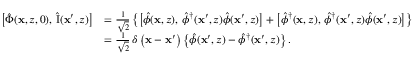Convert formula to latex. <formula><loc_0><loc_0><loc_500><loc_500>\begin{array} { r l } { \left [ \hat { \Phi } ( x , z , 0 ) , \, \hat { I } ( x ^ { \prime } , z ) \right ] } & { = \frac { 1 } { \sqrt { 2 } } \left \{ \left [ \hat { \phi } ( x , z ) , \, \hat { \phi } ^ { \dagger } ( x ^ { \prime } , z ) \hat { \phi } ( x ^ { \prime } , z ) \right ] + \left [ \hat { \phi } ^ { \dagger } ( x , z ) , \, \hat { \phi } ^ { \dagger } ( x ^ { \prime } , z ) \hat { \phi } ( x ^ { \prime } , z ) \right ] \right \} } \\ & { = \frac { 1 } { \sqrt { 2 } } \, \delta \left ( x - x ^ { \prime } \right ) \left \{ \hat { \phi } ( x ^ { \prime } , z ) - \hat { \phi } ^ { \dagger } ( x ^ { \prime } , z ) \right \} . } \end{array}</formula> 